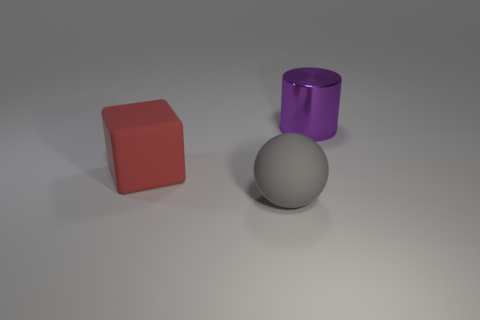How many other things have the same material as the purple thing?
Your response must be concise. 0. What is the size of the rubber thing to the right of the block?
Ensure brevity in your answer.  Large. There is a matte object that is behind the matte object in front of the red matte cube; what is its shape?
Offer a terse response. Cube. There is a big purple thing that is on the right side of the big rubber thing that is to the right of the big red matte object; how many large red matte blocks are in front of it?
Ensure brevity in your answer.  1. Are there fewer gray objects that are behind the large shiny cylinder than gray matte spheres?
Your answer should be very brief. Yes. Is there anything else that is the same shape as the large red matte object?
Your answer should be compact. No. The large thing that is in front of the big rubber block has what shape?
Your answer should be compact. Sphere. What shape is the large rubber object behind the gray matte thing right of the matte object that is behind the gray object?
Provide a succinct answer. Cube. What number of objects are either large matte cubes or brown shiny balls?
Give a very brief answer. 1. There is a rubber object right of the large red block; does it have the same shape as the thing behind the large matte block?
Give a very brief answer. No. 